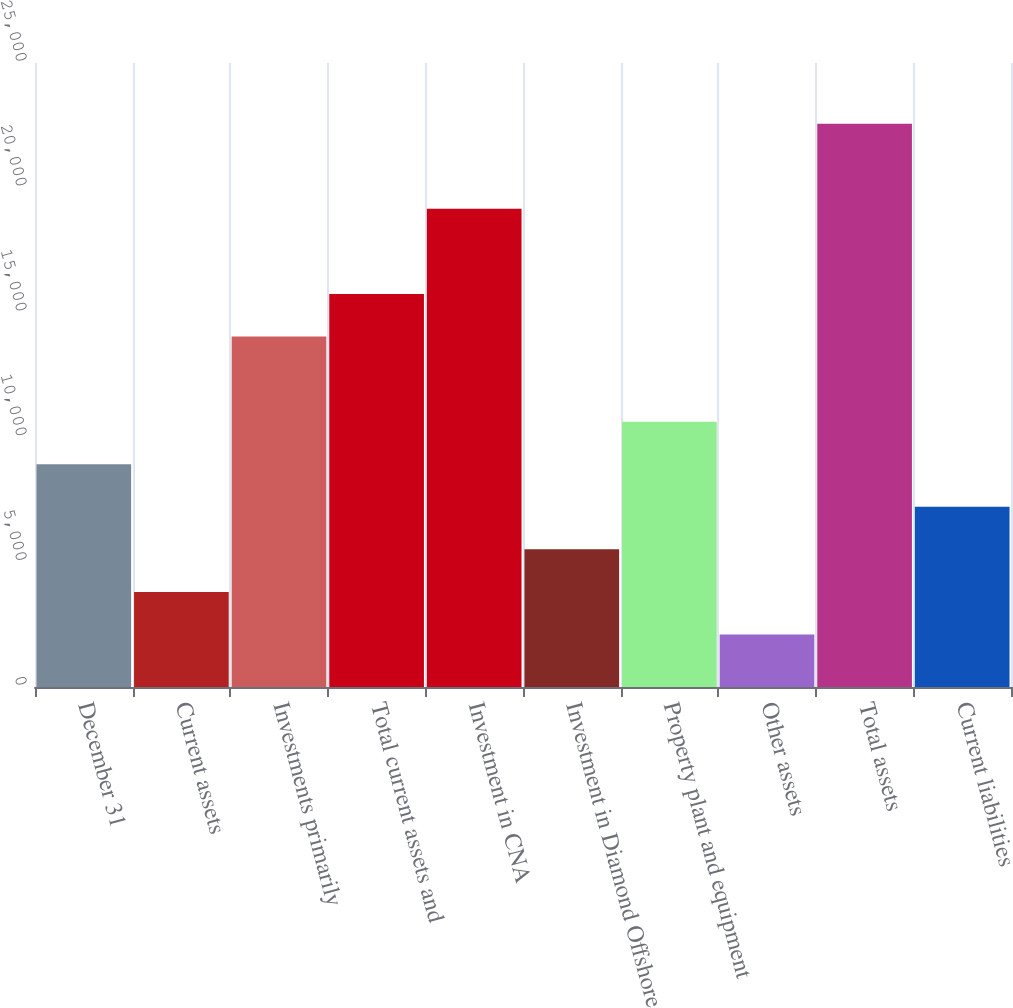Convert chart to OTSL. <chart><loc_0><loc_0><loc_500><loc_500><bar_chart><fcel>December 31<fcel>Current assets<fcel>Investments primarily<fcel>Total current assets and<fcel>Investment in CNA<fcel>Investment in Diamond Offshore<fcel>Property plant and equipment<fcel>Other assets<fcel>Total assets<fcel>Current liabilities<nl><fcel>8926<fcel>3810.46<fcel>14041.5<fcel>15746.7<fcel>19157.1<fcel>5515.64<fcel>10631.2<fcel>2105.28<fcel>22567.4<fcel>7220.82<nl></chart> 